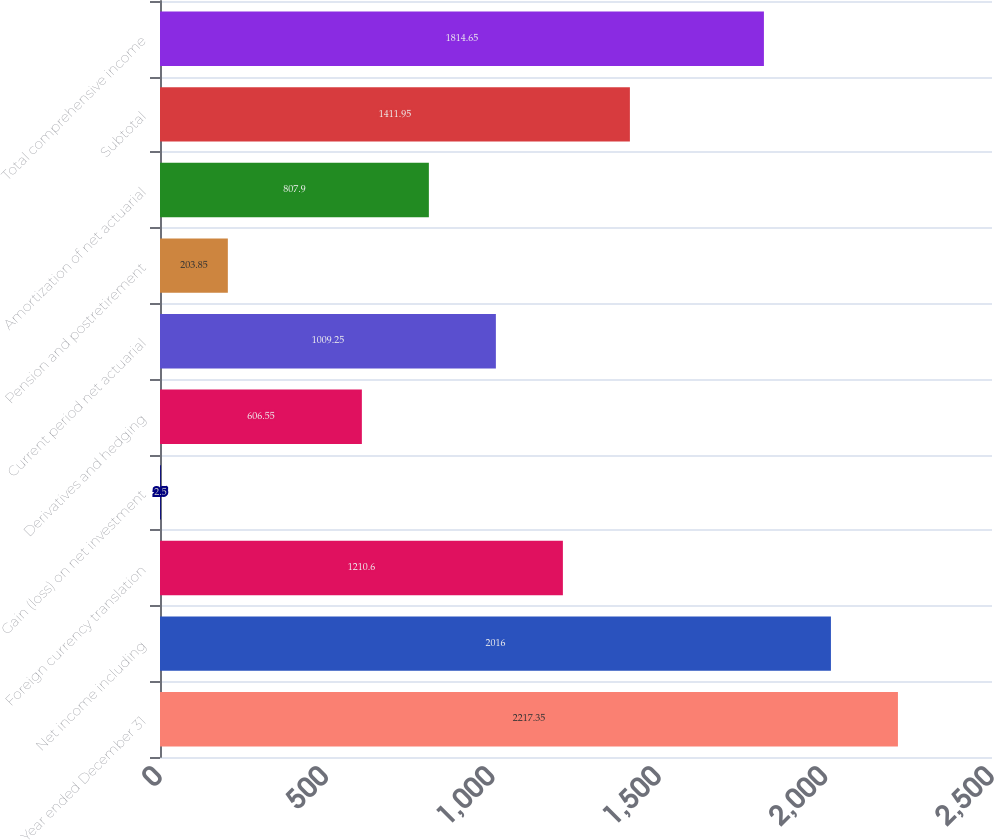Convert chart to OTSL. <chart><loc_0><loc_0><loc_500><loc_500><bar_chart><fcel>Year ended December 31<fcel>Net income including<fcel>Foreign currency translation<fcel>Gain (loss) on net investment<fcel>Derivatives and hedging<fcel>Current period net actuarial<fcel>Pension and postretirement<fcel>Amortization of net actuarial<fcel>Subtotal<fcel>Total comprehensive income<nl><fcel>2217.35<fcel>2016<fcel>1210.6<fcel>2.5<fcel>606.55<fcel>1009.25<fcel>203.85<fcel>807.9<fcel>1411.95<fcel>1814.65<nl></chart> 